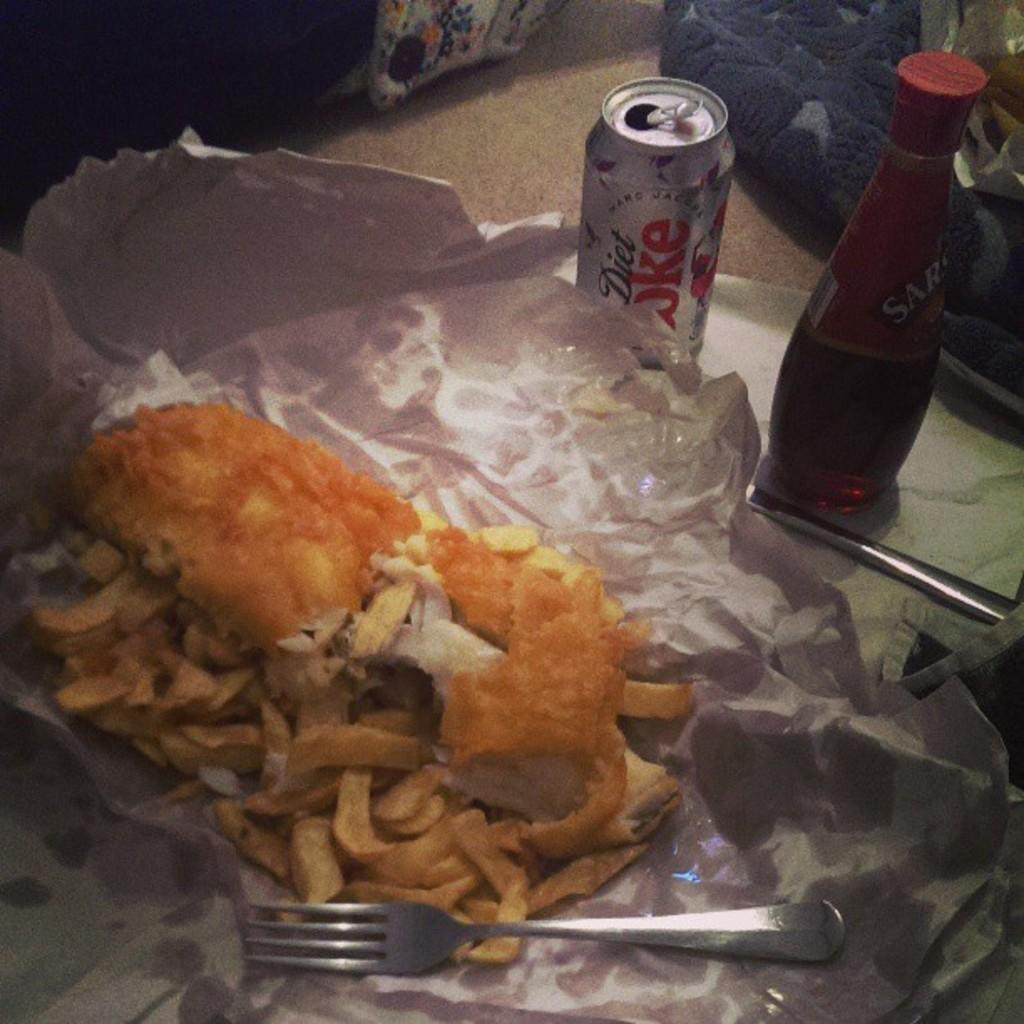<image>
Provide a brief description of the given image. A can of diet coke sits next to food. 